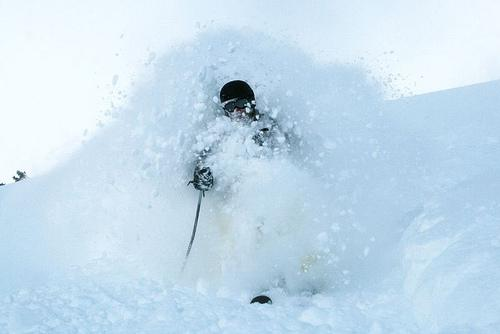Question: who is in the picture?
Choices:
A. Bride and groom.
B. A skier.
C. Family.
D. A group of children.
Answer with the letter. Answer: B Question: what is the person doing?
Choices:
A. Dancing.
B. Skateboarding.
C. Running.
D. Skiing.
Answer with the letter. Answer: D Question: what is on the skier's head?
Choices:
A. A football helmet.
B. A hat.
C. A baseball cap.
D. A lampshade.
Answer with the letter. Answer: B 